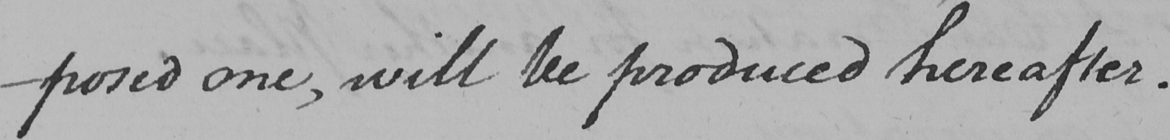Can you read and transcribe this handwriting? -posed one , will be produced hereafter . 